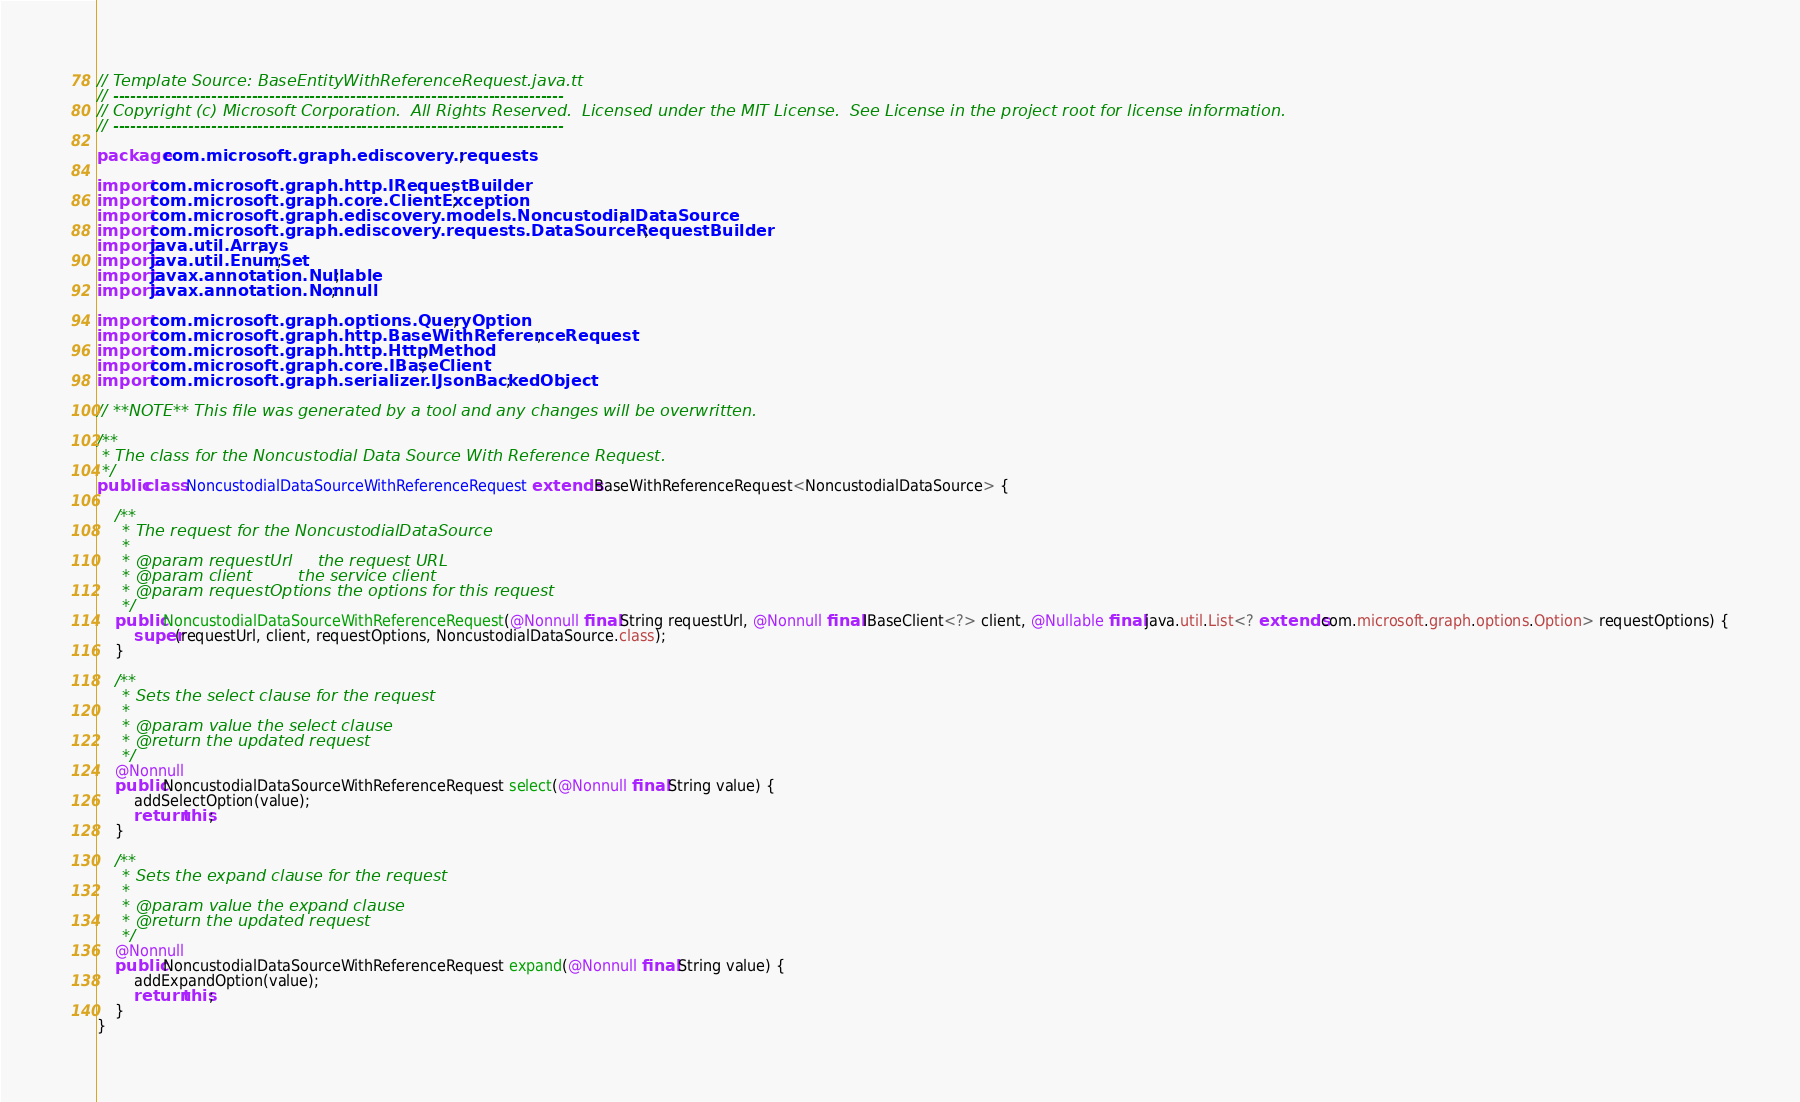Convert code to text. <code><loc_0><loc_0><loc_500><loc_500><_Java_>// Template Source: BaseEntityWithReferenceRequest.java.tt
// ------------------------------------------------------------------------------
// Copyright (c) Microsoft Corporation.  All Rights Reserved.  Licensed under the MIT License.  See License in the project root for license information.
// ------------------------------------------------------------------------------

package com.microsoft.graph.ediscovery.requests;

import com.microsoft.graph.http.IRequestBuilder;
import com.microsoft.graph.core.ClientException;
import com.microsoft.graph.ediscovery.models.NoncustodialDataSource;
import com.microsoft.graph.ediscovery.requests.DataSourceRequestBuilder;
import java.util.Arrays;
import java.util.EnumSet;
import javax.annotation.Nullable;
import javax.annotation.Nonnull;

import com.microsoft.graph.options.QueryOption;
import com.microsoft.graph.http.BaseWithReferenceRequest;
import com.microsoft.graph.http.HttpMethod;
import com.microsoft.graph.core.IBaseClient;
import com.microsoft.graph.serializer.IJsonBackedObject;

// **NOTE** This file was generated by a tool and any changes will be overwritten.

/**
 * The class for the Noncustodial Data Source With Reference Request.
 */
public class NoncustodialDataSourceWithReferenceRequest extends BaseWithReferenceRequest<NoncustodialDataSource> {

    /**
     * The request for the NoncustodialDataSource
     *
     * @param requestUrl     the request URL
     * @param client         the service client
     * @param requestOptions the options for this request
     */
    public NoncustodialDataSourceWithReferenceRequest(@Nonnull final String requestUrl, @Nonnull final IBaseClient<?> client, @Nullable final java.util.List<? extends com.microsoft.graph.options.Option> requestOptions) {
        super(requestUrl, client, requestOptions, NoncustodialDataSource.class);
    }

    /**
     * Sets the select clause for the request
     *
     * @param value the select clause
     * @return the updated request
     */
    @Nonnull
    public NoncustodialDataSourceWithReferenceRequest select(@Nonnull final String value) {
        addSelectOption(value);
        return this;
    }

    /**
     * Sets the expand clause for the request
     *
     * @param value the expand clause
     * @return the updated request
     */
    @Nonnull
    public NoncustodialDataSourceWithReferenceRequest expand(@Nonnull final String value) {
        addExpandOption(value);
        return this;
    }
}
</code> 